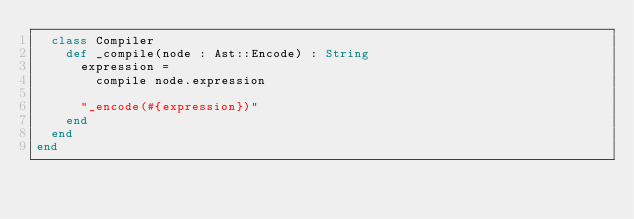<code> <loc_0><loc_0><loc_500><loc_500><_Crystal_>  class Compiler
    def _compile(node : Ast::Encode) : String
      expression =
        compile node.expression

      "_encode(#{expression})"
    end
  end
end
</code> 